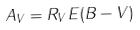Convert formula to latex. <formula><loc_0><loc_0><loc_500><loc_500>A _ { V } = R _ { V } E ( B - V )</formula> 